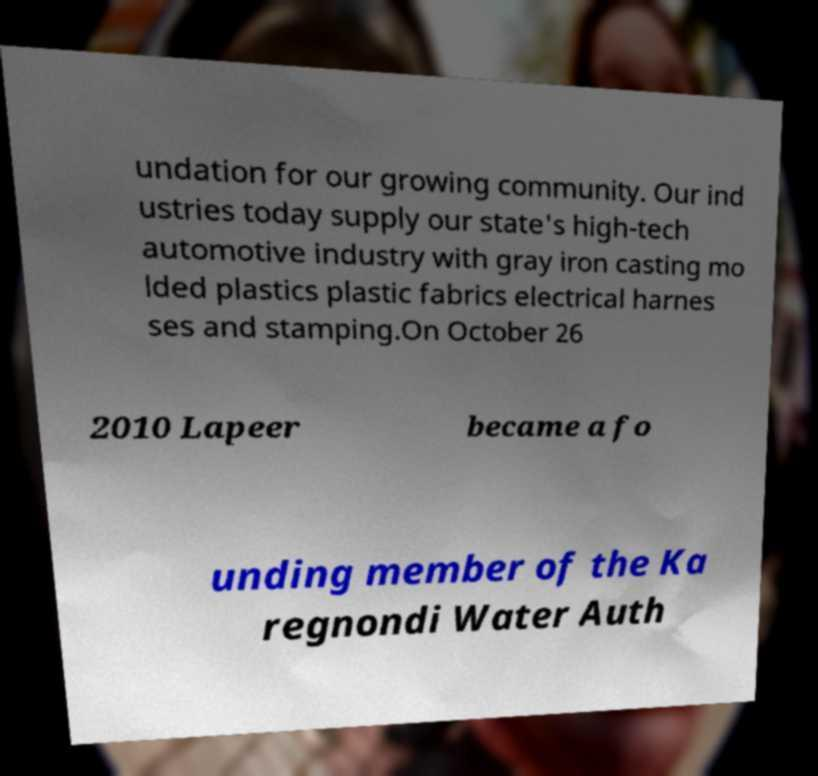I need the written content from this picture converted into text. Can you do that? undation for our growing community. Our ind ustries today supply our state's high-tech automotive industry with gray iron casting mo lded plastics plastic fabrics electrical harnes ses and stamping.On October 26 2010 Lapeer became a fo unding member of the Ka regnondi Water Auth 